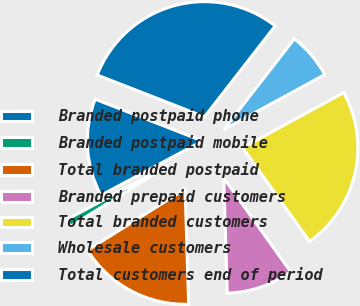Convert chart to OTSL. <chart><loc_0><loc_0><loc_500><loc_500><pie_chart><fcel>Branded postpaid phone<fcel>Branded postpaid mobile<fcel>Total branded postpaid<fcel>Branded prepaid customers<fcel>Total branded customers<fcel>Wholesale customers<fcel>Total customers end of period<nl><fcel>13.73%<fcel>1.09%<fcel>16.58%<fcel>9.38%<fcel>23.08%<fcel>6.53%<fcel>29.6%<nl></chart> 